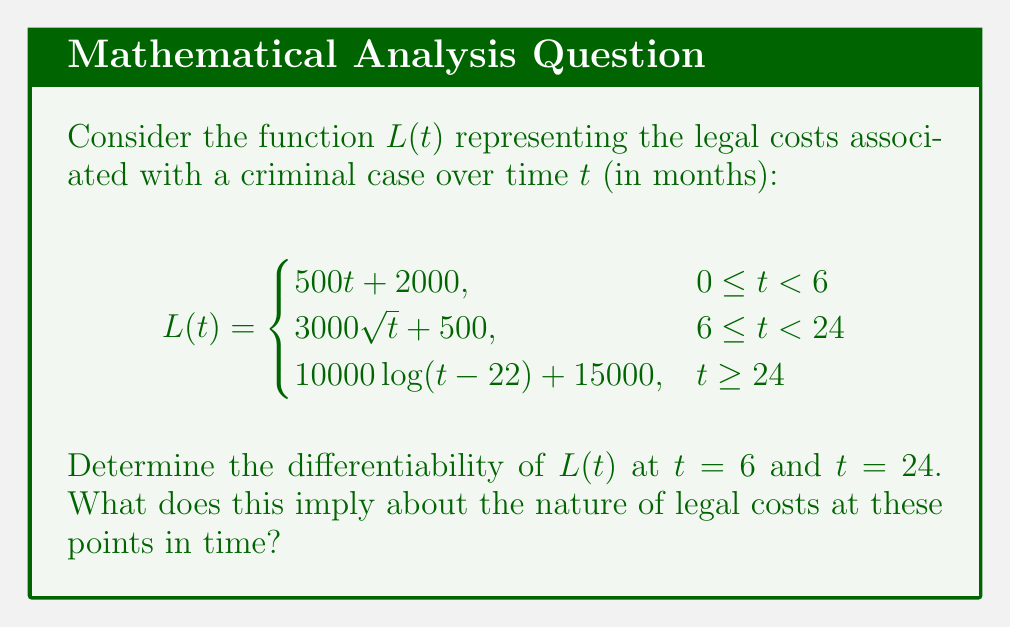Can you solve this math problem? To determine the differentiability of $L(t)$ at $t = 6$ and $t = 24$, we need to check if the function is continuous and if the left-hand and right-hand derivatives exist and are equal at these points.

1. At $t = 6$:

   Left limit: $\lim_{t \to 6^-} L(t) = 500(6) + 2000 = 5000$
   Right limit: $\lim_{t \to 6^+} L(t) = 3000\sqrt{6} + 500 = 7854.10$
   
   The function is not continuous at $t = 6$, so it cannot be differentiable at this point.

2. At $t = 24$:

   Left limit: $\lim_{t \to 24^-} L(t) = 3000\sqrt{24} + 500 = 15196.15$
   Right limit: $\lim_{t \to 24^+} L(t) = 10000\log(24-22) + 15000 = 15000$
   
   The function is continuous at $t = 24$.

   Left-hand derivative:
   $$\lim_{h \to 0^-} \frac{L(24+h) - L(24)}{h} = \lim_{h \to 0^-} \frac{3000\sqrt{24+h} + 500 - (3000\sqrt{24} + 500)}{h} = \frac{3000}{2\sqrt{24}} = 306.19$$

   Right-hand derivative:
   $$\lim_{h \to 0^+} \frac{L(24+h) - L(24)}{h} = \lim_{h \to 0^+} \frac{10000\log(2+h) + 15000 - 15000}{h} = \frac{10000}{2} = 5000$$

   The left-hand and right-hand derivatives are not equal, so $L(t)$ is not differentiable at $t = 24$.

These results imply that there are sudden changes in the rate of legal costs at both 6 months and 24 months into the case. At 6 months, there's a jump in the total cost, while at 24 months, there's a significant change in the rate of cost increase.
Answer: $L(t)$ is not differentiable at $t = 6$ or $t = 24$. 